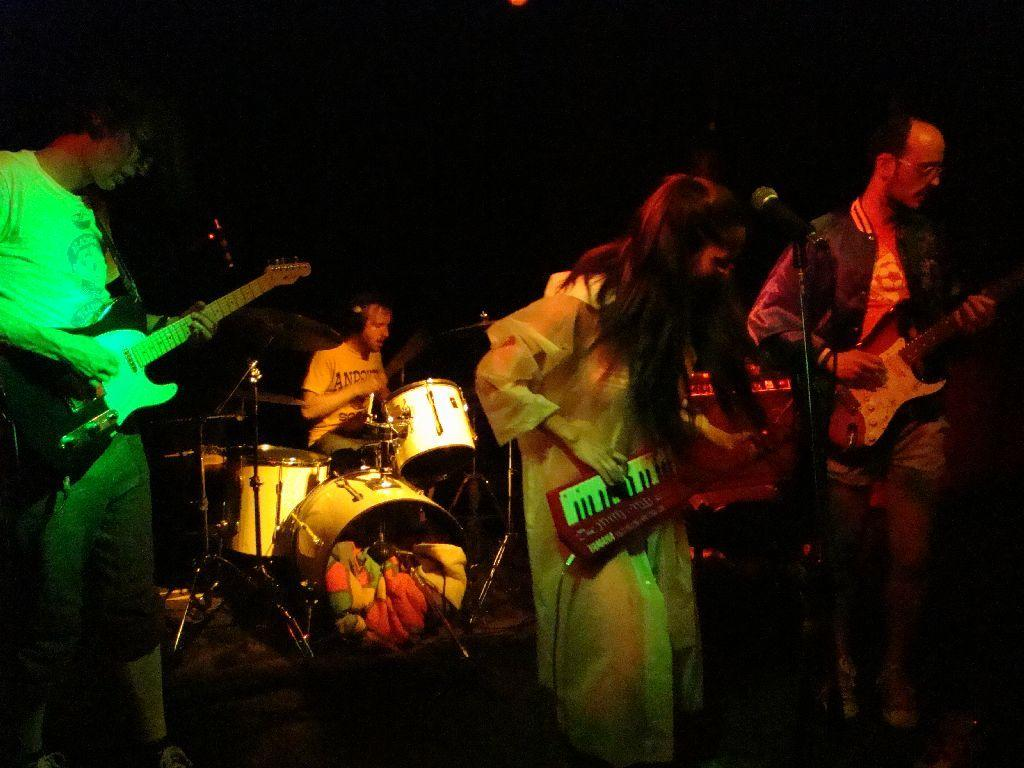How many people are present in the image? There are four people in the image. What are the people doing in the image? The people are playing musical instruments. Can you describe the overall appearance of the image? The image has a dark appearance. What type of trees can be seen in the background of the image? There are no trees visible in the image; it only features four people playing musical instruments in a dark setting. 